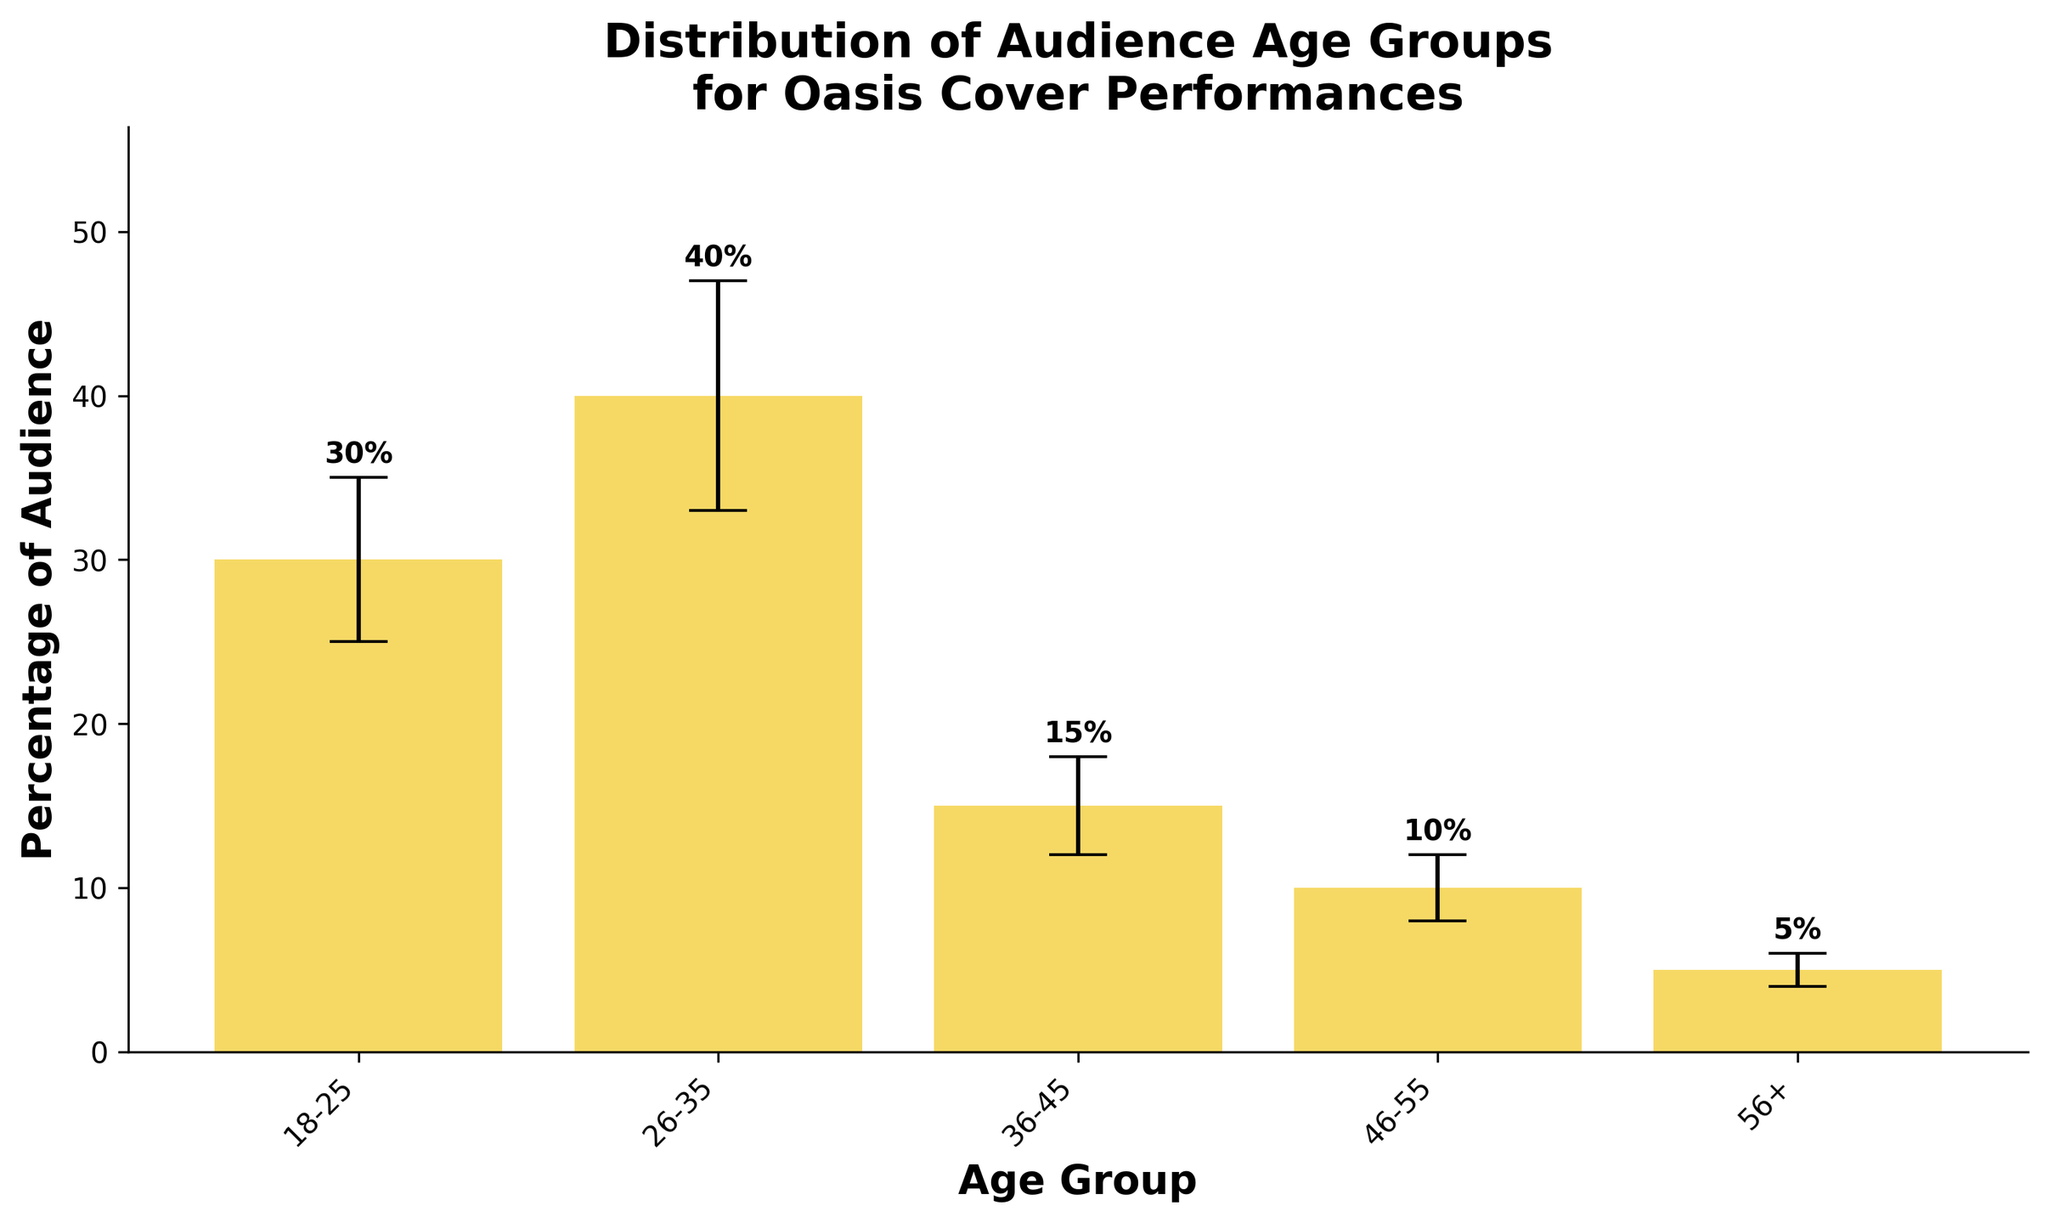What is the title of the plot? The title is usually displayed at the top of the plot and summarizes what the plot is about. In this case, it can be found above the bars and error bars.
Answer: Distribution of Audience Age Groups for Oasis Cover Performances What percentage of the audience is in the 26-35 age group? The percentage for each age group is indicated by the height of the respective bar. For the 26-35 age group, the bar reaches 40%.
Answer: 40% Which age group has the largest standard deviation in audience percentage? The standard deviation can be inferred from the length of the error bars. The age group with the longest error bar has the largest standard deviation, which in this example belongs to the 26-35 age group with a standard deviation of 7%.
Answer: 26-35 Compare the audience percentages between the 18-25 and 36-45 age groups. Look at the heights of the bars for the 18-25 and 36-45 age groups. The 18-25 age group has a bar height of 30%, while the 36-45 age group has a bar height of 15%. Therefore, the 18-25 age group has twice the percentage of the 36-45 age group.
Answer: 18-25 has twice the percentage of 36-45 What is the combined audience percentage of the two oldest age groups (46-55 and 56+)? Add the percentages of the 46-55 age group and the 56+ age group. The 46-55 group has 10% and the 56+ group has 5%. So, the combined percentage is 10% + 5%.
Answer: 15% What is the smallest audience percentage among all age groups, and which age group does it belong to? The smallest audience percentage is represented by the shortest bar. The shortest bar corresponds to the 56+ age group at 5%.
Answer: 5%, 56+ How do the error bars for the 18-25 and 46-55 age groups compare? Compare the lengths of the error bars of the 18-25 and 46-55 age groups. The error bar for the 18-25 age group is 5%, while the error bar for the 46-55 age group is 2%. This shows that there is more variability in the audience percentage for the 18-25 age group.
Answer: 18-25 has a longer error bar Which age group's audience percentage is 10%? Check the heights of the bars and find the one that reaches the 10% mark. The 46-55 age group has an audience percentage of 10%.
Answer: 46-55 